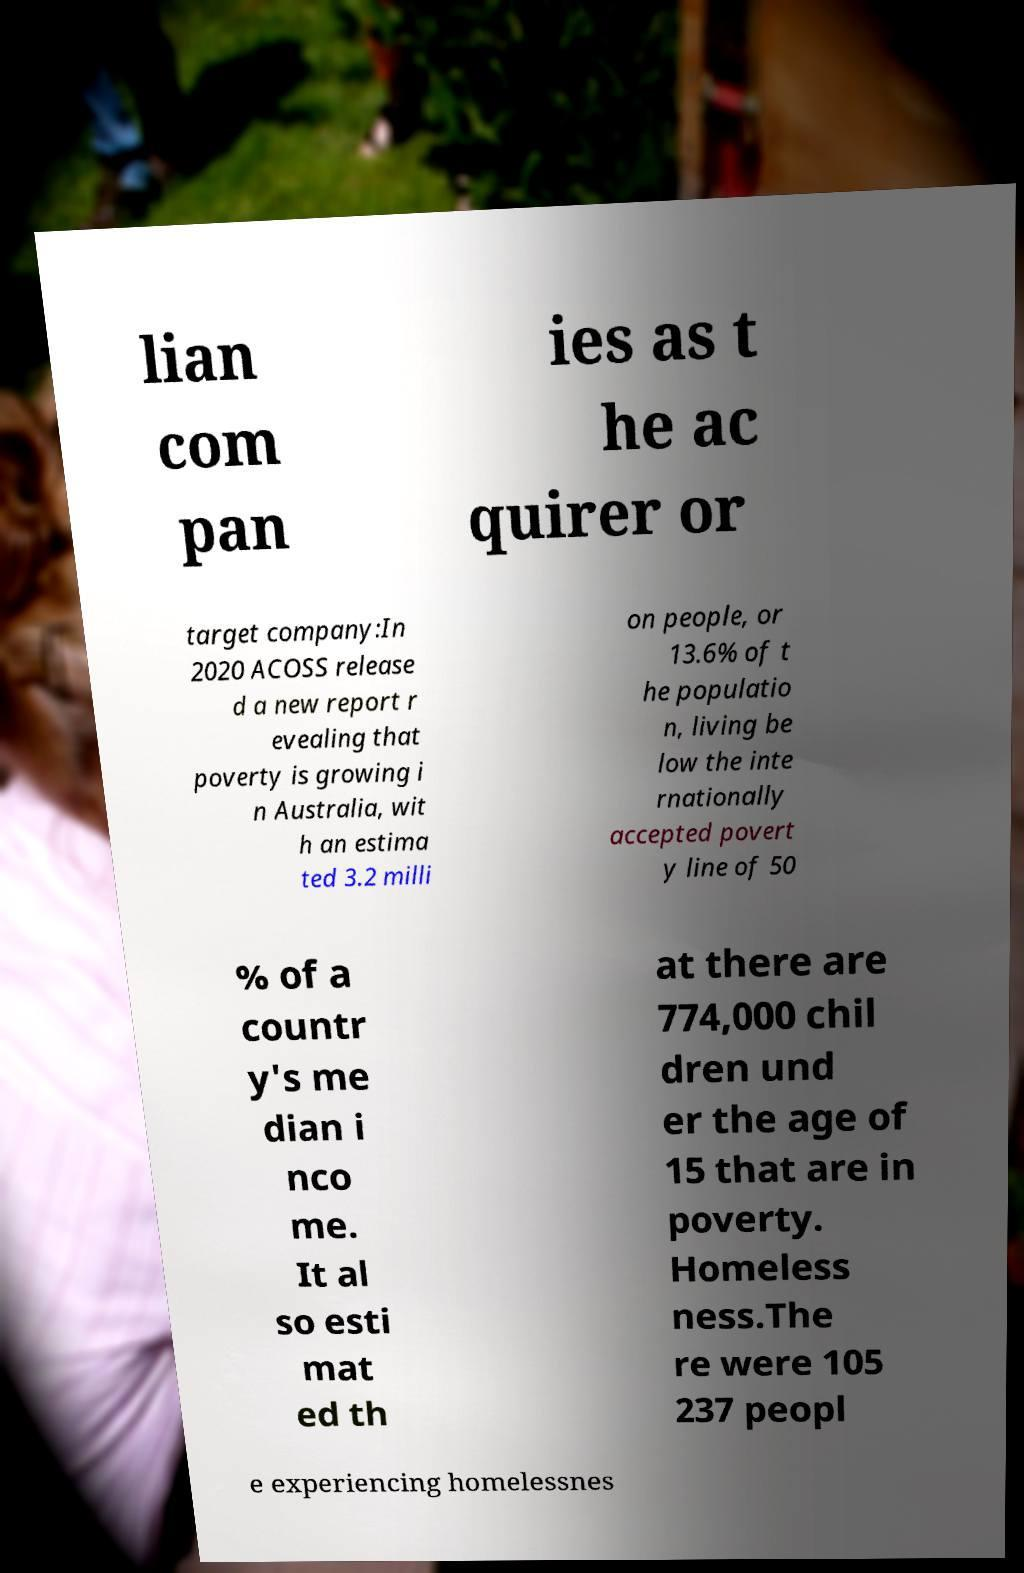Could you extract and type out the text from this image? lian com pan ies as t he ac quirer or target company:In 2020 ACOSS release d a new report r evealing that poverty is growing i n Australia, wit h an estima ted 3.2 milli on people, or 13.6% of t he populatio n, living be low the inte rnationally accepted povert y line of 50 % of a countr y's me dian i nco me. It al so esti mat ed th at there are 774,000 chil dren und er the age of 15 that are in poverty. Homeless ness.The re were 105 237 peopl e experiencing homelessnes 